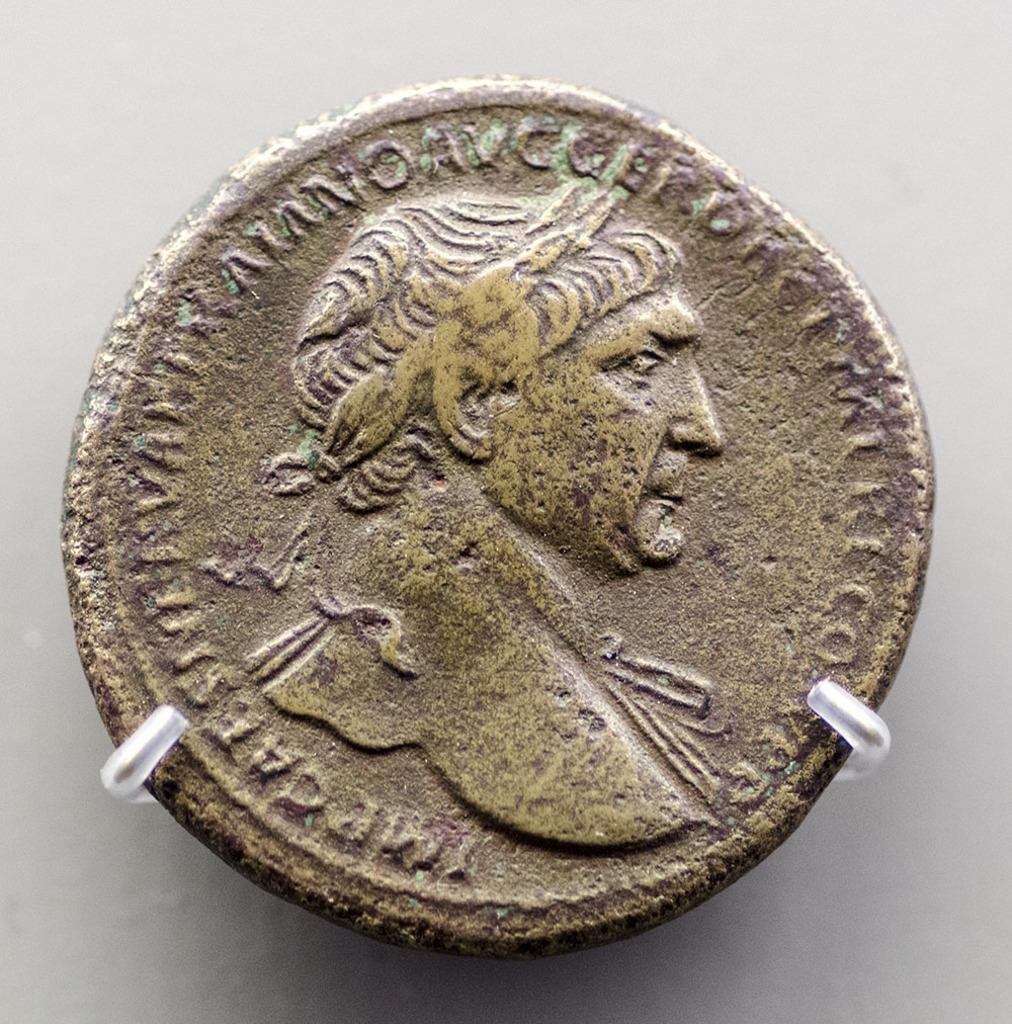What object is in the image? There is a coin in the image. How is the coin positioned in the image? The coin is placed on hooks. What can be read on the coin? There is text on the coin. What image is featured on the coin? There is a human figure on the coin. What is the color of the background in the image? The background of the image is a white surface. How many rabbits are hopping around the coin in the image? There are no rabbits present in the image; it only features a coin on hooks. What religious symbol can be seen on the coin? There is no religious symbol present on the coin; it only has text and a human figure. 